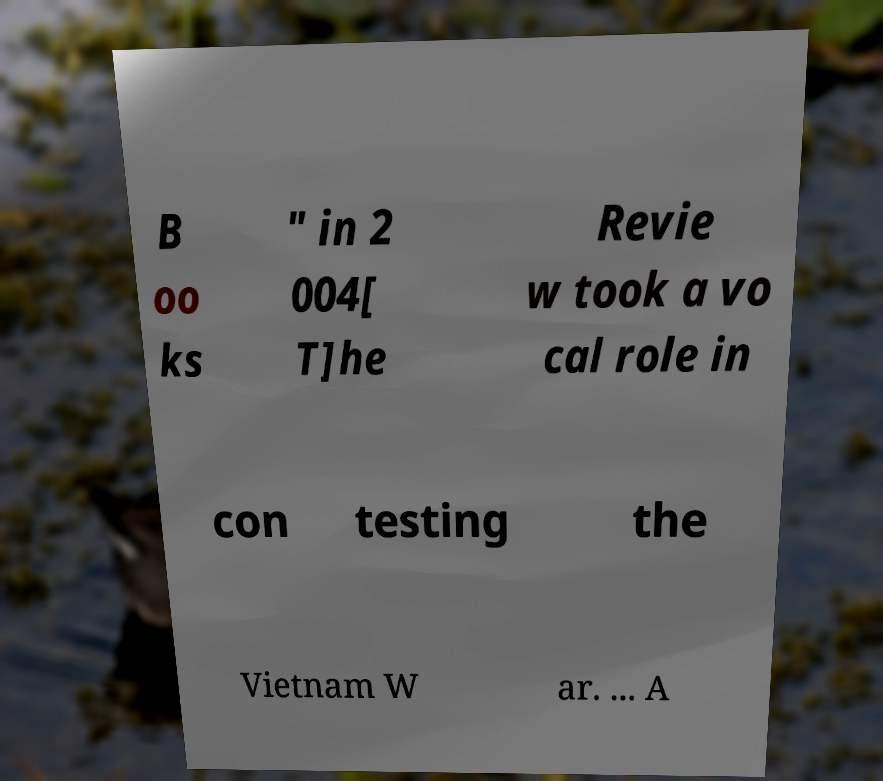There's text embedded in this image that I need extracted. Can you transcribe it verbatim? B oo ks " in 2 004[ T]he Revie w took a vo cal role in con testing the Vietnam W ar. ... A 